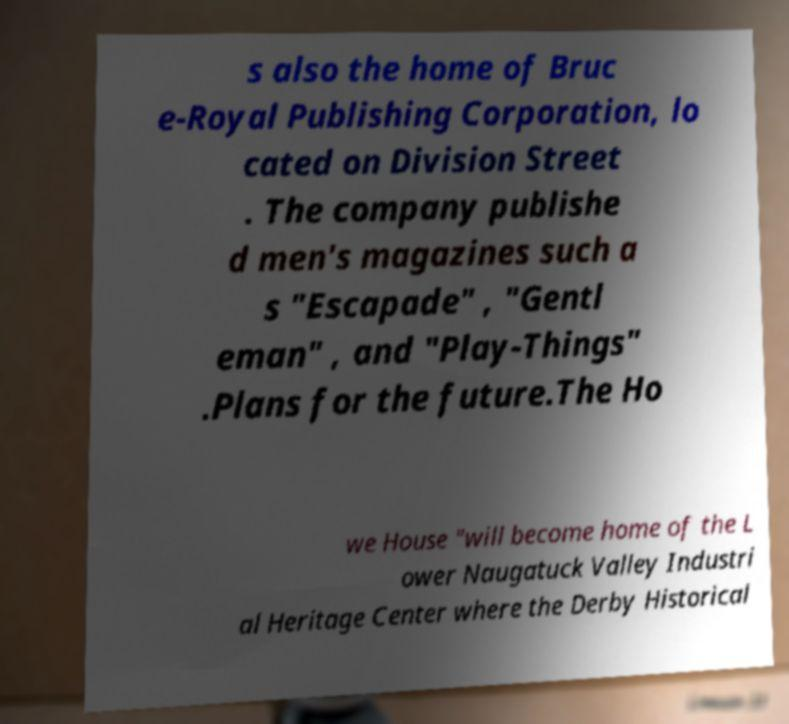I need the written content from this picture converted into text. Can you do that? s also the home of Bruc e-Royal Publishing Corporation, lo cated on Division Street . The company publishe d men's magazines such a s "Escapade" , "Gentl eman" , and "Play-Things" .Plans for the future.The Ho we House "will become home of the L ower Naugatuck Valley Industri al Heritage Center where the Derby Historical 